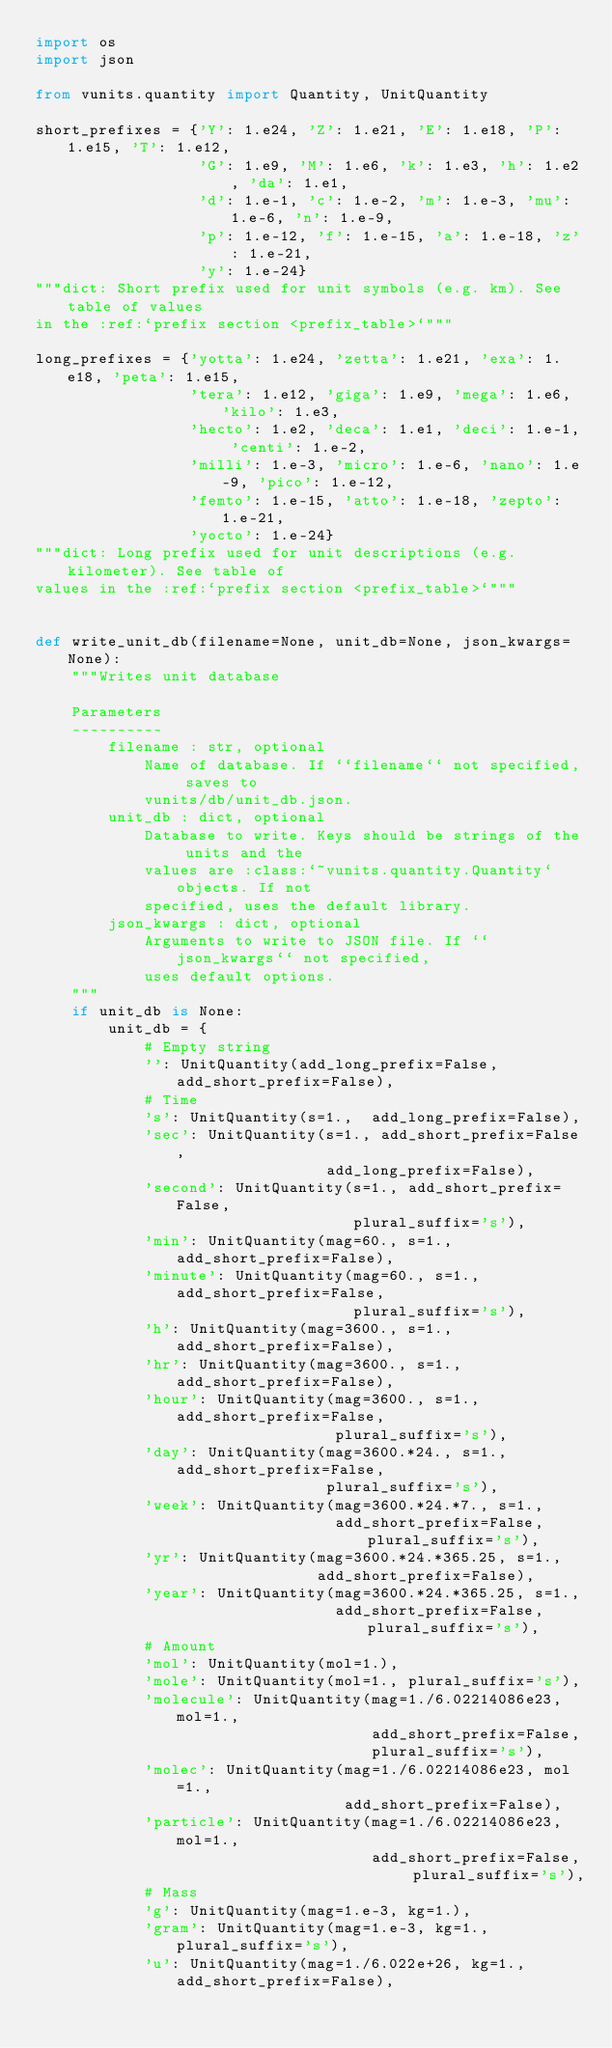<code> <loc_0><loc_0><loc_500><loc_500><_Python_>import os
import json

from vunits.quantity import Quantity, UnitQuantity

short_prefixes = {'Y': 1.e24, 'Z': 1.e21, 'E': 1.e18, 'P': 1.e15, 'T': 1.e12,
                  'G': 1.e9, 'M': 1.e6, 'k': 1.e3, 'h': 1.e2, 'da': 1.e1,
                  'd': 1.e-1, 'c': 1.e-2, 'm': 1.e-3, 'mu': 1.e-6, 'n': 1.e-9,
                  'p': 1.e-12, 'f': 1.e-15, 'a': 1.e-18, 'z': 1.e-21,
                  'y': 1.e-24}
"""dict: Short prefix used for unit symbols (e.g. km). See table of values
in the :ref:`prefix section <prefix_table>`"""

long_prefixes = {'yotta': 1.e24, 'zetta': 1.e21, 'exa': 1.e18, 'peta': 1.e15,
                 'tera': 1.e12, 'giga': 1.e9, 'mega': 1.e6, 'kilo': 1.e3,
                 'hecto': 1.e2, 'deca': 1.e1, 'deci': 1.e-1, 'centi': 1.e-2,
                 'milli': 1.e-3, 'micro': 1.e-6, 'nano': 1.e-9, 'pico': 1.e-12,
                 'femto': 1.e-15, 'atto': 1.e-18, 'zepto': 1.e-21,
                 'yocto': 1.e-24}
"""dict: Long prefix used for unit descriptions (e.g. kilometer). See table of
values in the :ref:`prefix section <prefix_table>`"""


def write_unit_db(filename=None, unit_db=None, json_kwargs=None):
    """Writes unit database

    Parameters
    ----------
        filename : str, optional
            Name of database. If ``filename`` not specified, saves to
            vunits/db/unit_db.json.
        unit_db : dict, optional
            Database to write. Keys should be strings of the units and the
            values are :class:`~vunits.quantity.Quantity` objects. If not
            specified, uses the default library.
        json_kwargs : dict, optional
            Arguments to write to JSON file. If ``json_kwargs`` not specified,
            uses default options.
    """
    if unit_db is None:
        unit_db = {
            # Empty string
            '': UnitQuantity(add_long_prefix=False, add_short_prefix=False),
            # Time
            's': UnitQuantity(s=1.,  add_long_prefix=False),
            'sec': UnitQuantity(s=1., add_short_prefix=False,
                                add_long_prefix=False),
            'second': UnitQuantity(s=1., add_short_prefix=False,
                                   plural_suffix='s'),
            'min': UnitQuantity(mag=60., s=1., add_short_prefix=False),
            'minute': UnitQuantity(mag=60., s=1., add_short_prefix=False,
                                   plural_suffix='s'),
            'h': UnitQuantity(mag=3600., s=1., add_short_prefix=False),
            'hr': UnitQuantity(mag=3600., s=1., add_short_prefix=False),
            'hour': UnitQuantity(mag=3600., s=1., add_short_prefix=False,
                                 plural_suffix='s'),
            'day': UnitQuantity(mag=3600.*24., s=1., add_short_prefix=False,
                                plural_suffix='s'),
            'week': UnitQuantity(mag=3600.*24.*7., s=1.,
                                 add_short_prefix=False, plural_suffix='s'),
            'yr': UnitQuantity(mag=3600.*24.*365.25, s=1.,
                               add_short_prefix=False),
            'year': UnitQuantity(mag=3600.*24.*365.25, s=1.,
                                 add_short_prefix=False, plural_suffix='s'),
            # Amount
            'mol': UnitQuantity(mol=1.),
            'mole': UnitQuantity(mol=1., plural_suffix='s'),
            'molecule': UnitQuantity(mag=1./6.02214086e23, mol=1.,
                                     add_short_prefix=False,
                                     plural_suffix='s'),
            'molec': UnitQuantity(mag=1./6.02214086e23, mol=1.,
                                  add_short_prefix=False),
            'particle': UnitQuantity(mag=1./6.02214086e23, mol=1.,
                                     add_short_prefix=False, plural_suffix='s'),
            # Mass
            'g': UnitQuantity(mag=1.e-3, kg=1.),
            'gram': UnitQuantity(mag=1.e-3, kg=1., plural_suffix='s'),
            'u': UnitQuantity(mag=1./6.022e+26, kg=1., add_short_prefix=False),</code> 